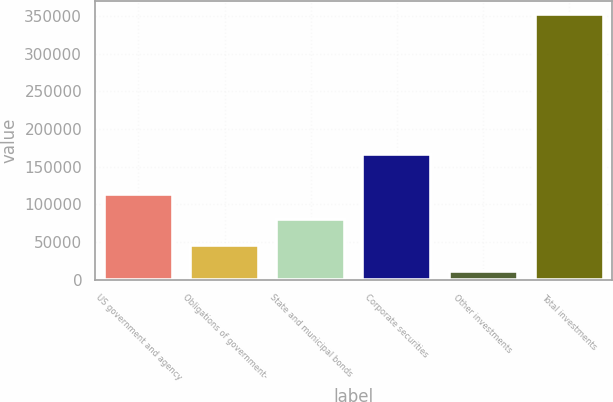<chart> <loc_0><loc_0><loc_500><loc_500><bar_chart><fcel>US government and agency<fcel>Obligations of government-<fcel>State and municipal bonds<fcel>Corporate securities<fcel>Other investments<fcel>Total investments<nl><fcel>114140<fcel>45903.3<fcel>80021.6<fcel>166420<fcel>11785<fcel>352968<nl></chart> 